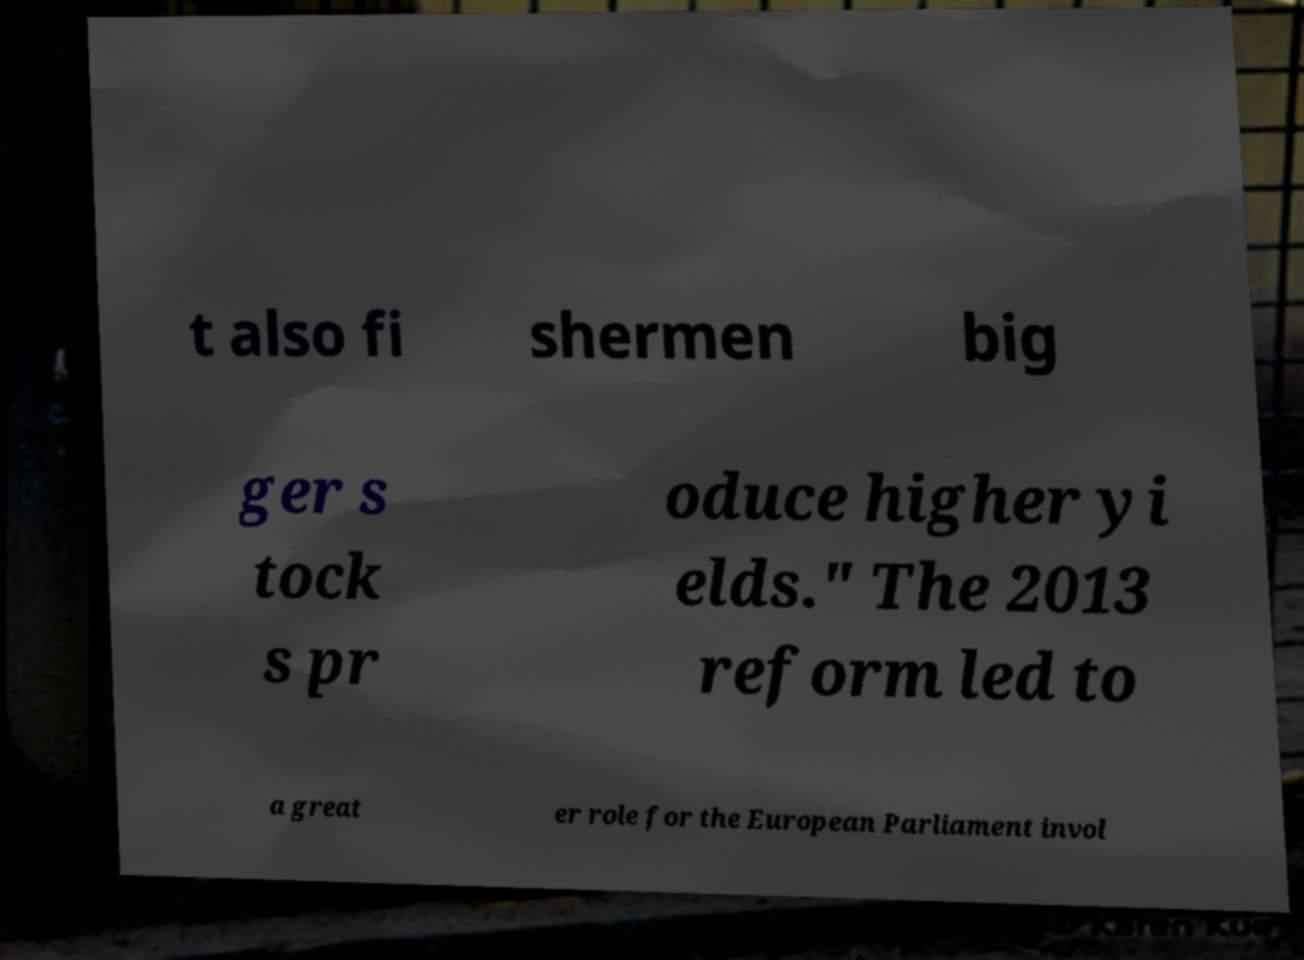Can you accurately transcribe the text from the provided image for me? t also fi shermen big ger s tock s pr oduce higher yi elds." The 2013 reform led to a great er role for the European Parliament invol 